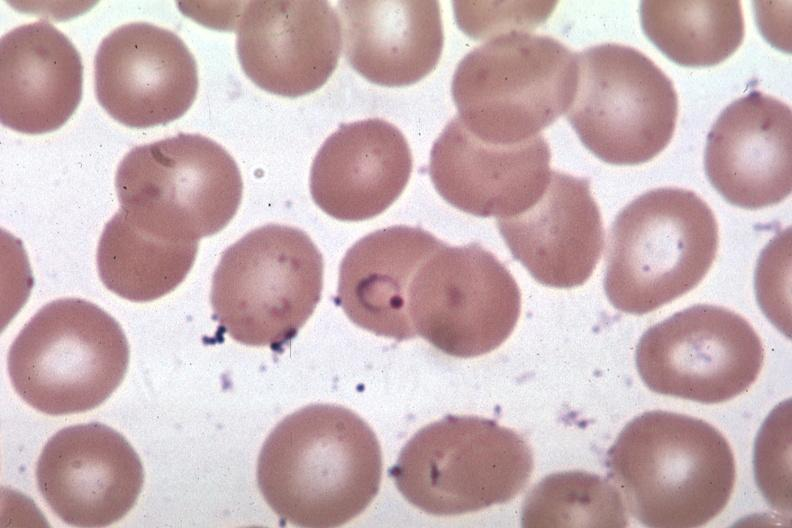does gastrointestinal show oil wrights excellent ring form?
Answer the question using a single word or phrase. No 